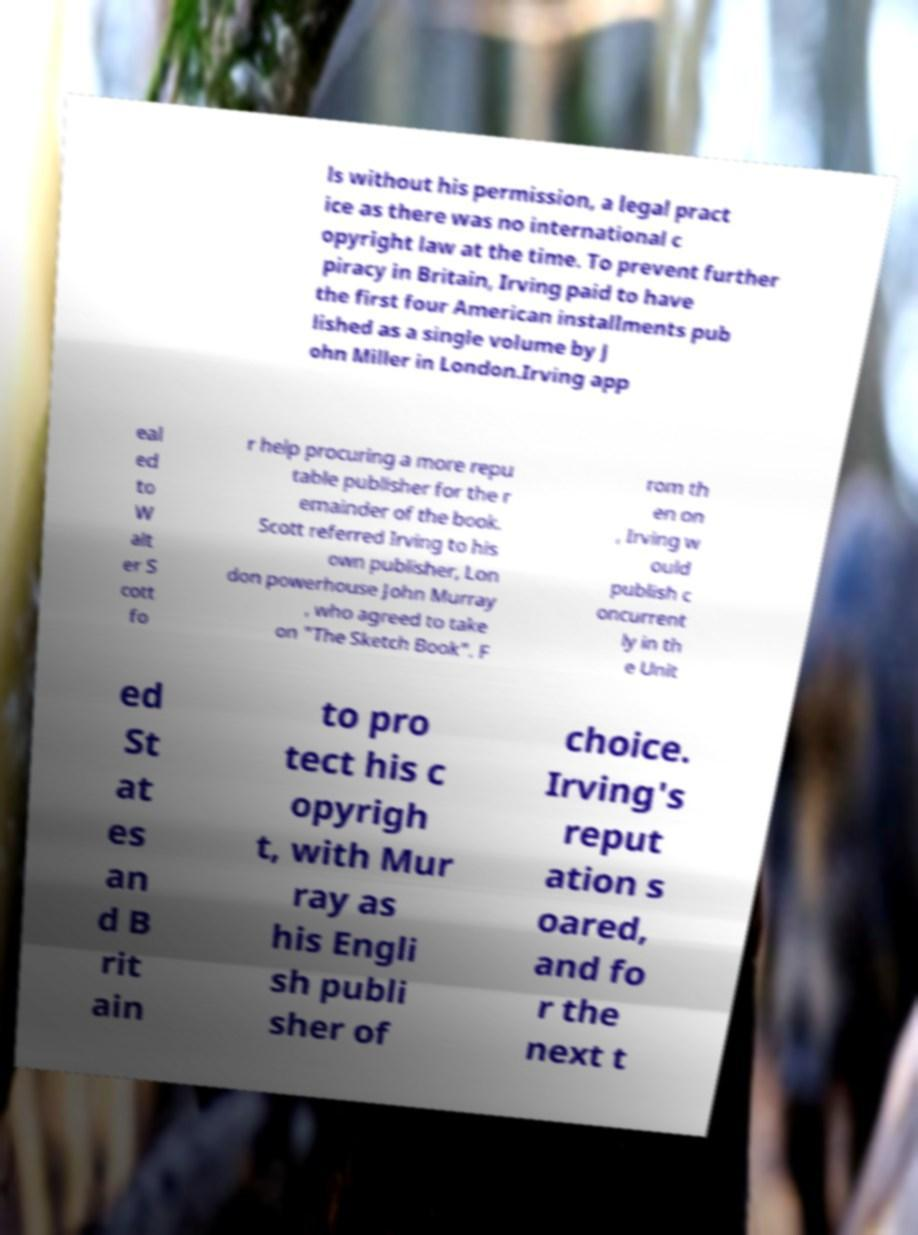Could you assist in decoding the text presented in this image and type it out clearly? ls without his permission, a legal pract ice as there was no international c opyright law at the time. To prevent further piracy in Britain, Irving paid to have the first four American installments pub lished as a single volume by J ohn Miller in London.Irving app eal ed to W alt er S cott fo r help procuring a more repu table publisher for the r emainder of the book. Scott referred Irving to his own publisher, Lon don powerhouse John Murray , who agreed to take on "The Sketch Book". F rom th en on , Irving w ould publish c oncurrent ly in th e Unit ed St at es an d B rit ain to pro tect his c opyrigh t, with Mur ray as his Engli sh publi sher of choice. Irving's reput ation s oared, and fo r the next t 